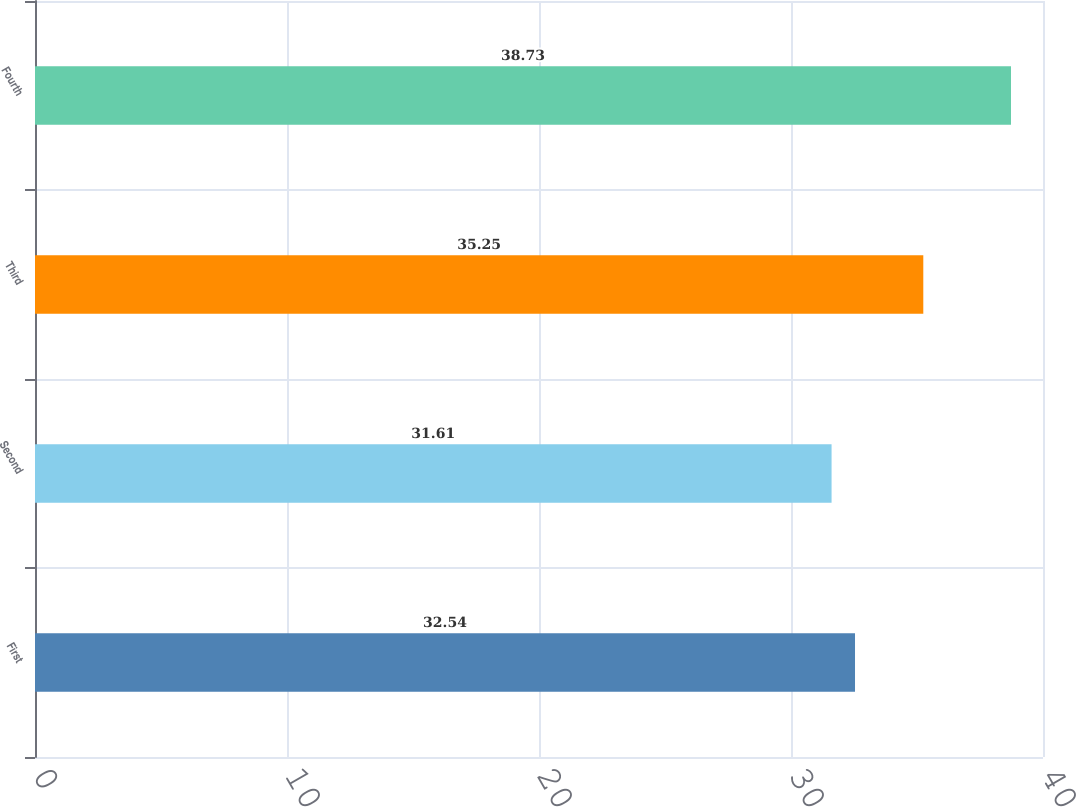Convert chart. <chart><loc_0><loc_0><loc_500><loc_500><bar_chart><fcel>First<fcel>Second<fcel>Third<fcel>Fourth<nl><fcel>32.54<fcel>31.61<fcel>35.25<fcel>38.73<nl></chart> 